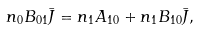Convert formula to latex. <formula><loc_0><loc_0><loc_500><loc_500>n _ { 0 } B _ { 0 1 } \bar { J } = n _ { 1 } A _ { 1 0 } + n _ { 1 } B _ { 1 0 } \bar { J } ,</formula> 